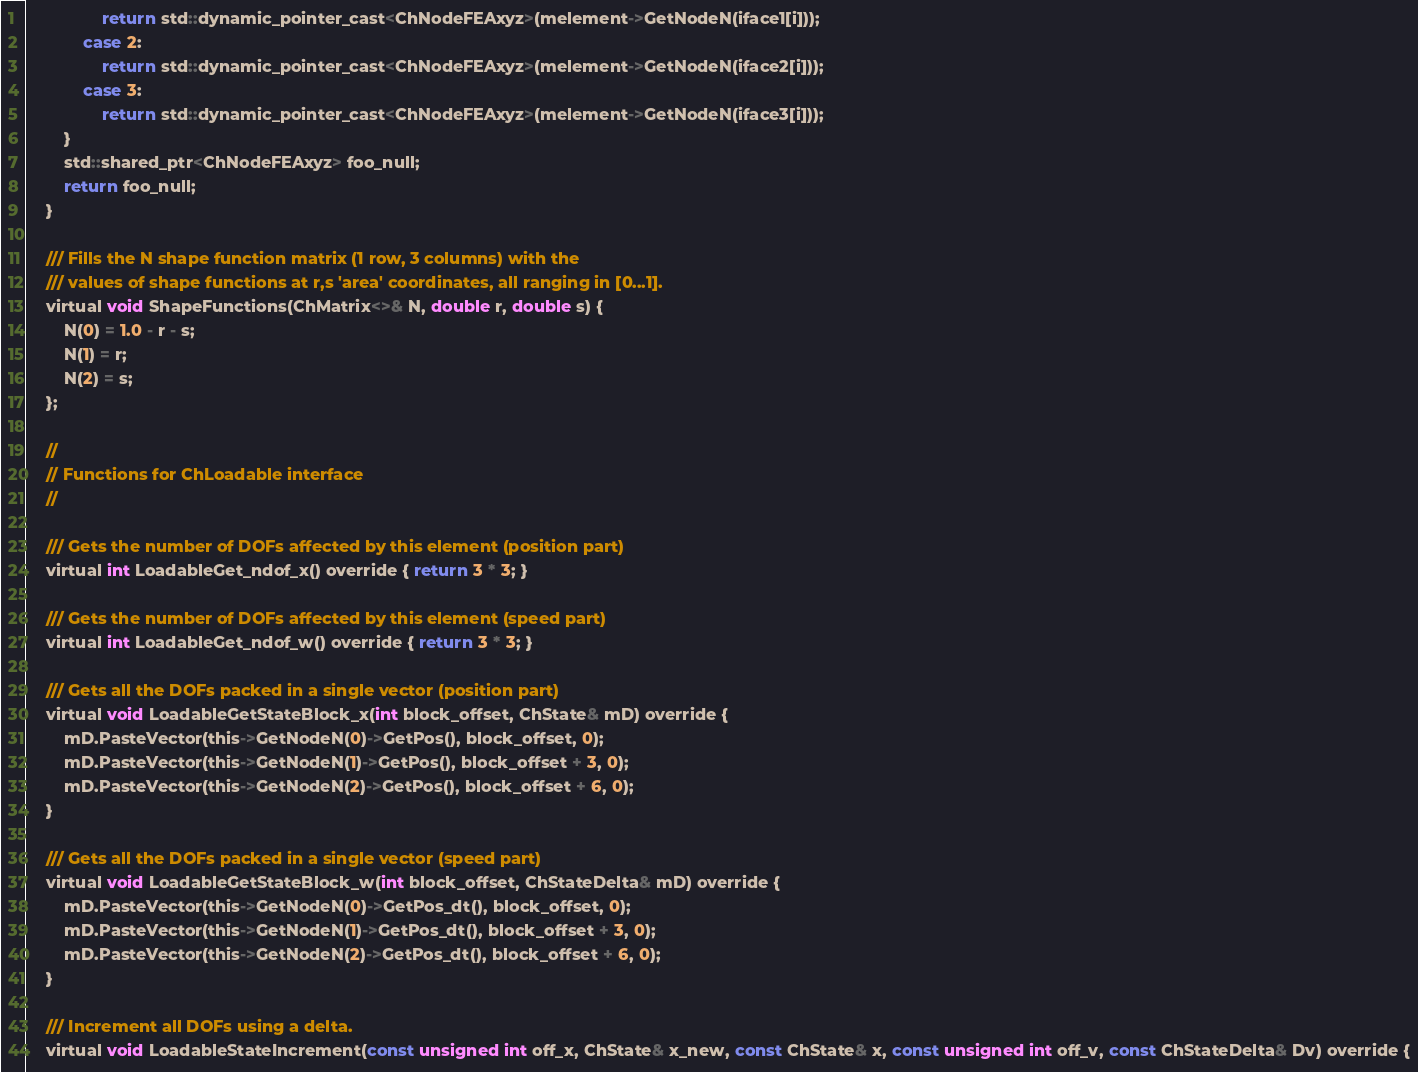<code> <loc_0><loc_0><loc_500><loc_500><_C_>                return std::dynamic_pointer_cast<ChNodeFEAxyz>(melement->GetNodeN(iface1[i]));
            case 2:
                return std::dynamic_pointer_cast<ChNodeFEAxyz>(melement->GetNodeN(iface2[i]));
            case 3:
                return std::dynamic_pointer_cast<ChNodeFEAxyz>(melement->GetNodeN(iface3[i]));
        }
        std::shared_ptr<ChNodeFEAxyz> foo_null;
        return foo_null;
    }

    /// Fills the N shape function matrix (1 row, 3 columns) with the
    /// values of shape functions at r,s 'area' coordinates, all ranging in [0...1].
    virtual void ShapeFunctions(ChMatrix<>& N, double r, double s) {
        N(0) = 1.0 - r - s;
        N(1) = r;
        N(2) = s;
    };

    //
    // Functions for ChLoadable interface
    //

    /// Gets the number of DOFs affected by this element (position part)
    virtual int LoadableGet_ndof_x() override { return 3 * 3; }

    /// Gets the number of DOFs affected by this element (speed part)
    virtual int LoadableGet_ndof_w() override { return 3 * 3; }

    /// Gets all the DOFs packed in a single vector (position part)
    virtual void LoadableGetStateBlock_x(int block_offset, ChState& mD) override {
        mD.PasteVector(this->GetNodeN(0)->GetPos(), block_offset, 0);
        mD.PasteVector(this->GetNodeN(1)->GetPos(), block_offset + 3, 0);
        mD.PasteVector(this->GetNodeN(2)->GetPos(), block_offset + 6, 0);
    }

    /// Gets all the DOFs packed in a single vector (speed part)
    virtual void LoadableGetStateBlock_w(int block_offset, ChStateDelta& mD) override {
        mD.PasteVector(this->GetNodeN(0)->GetPos_dt(), block_offset, 0);
        mD.PasteVector(this->GetNodeN(1)->GetPos_dt(), block_offset + 3, 0);
        mD.PasteVector(this->GetNodeN(2)->GetPos_dt(), block_offset + 6, 0);
    }

    /// Increment all DOFs using a delta.
    virtual void LoadableStateIncrement(const unsigned int off_x, ChState& x_new, const ChState& x, const unsigned int off_v, const ChStateDelta& Dv) override {</code> 